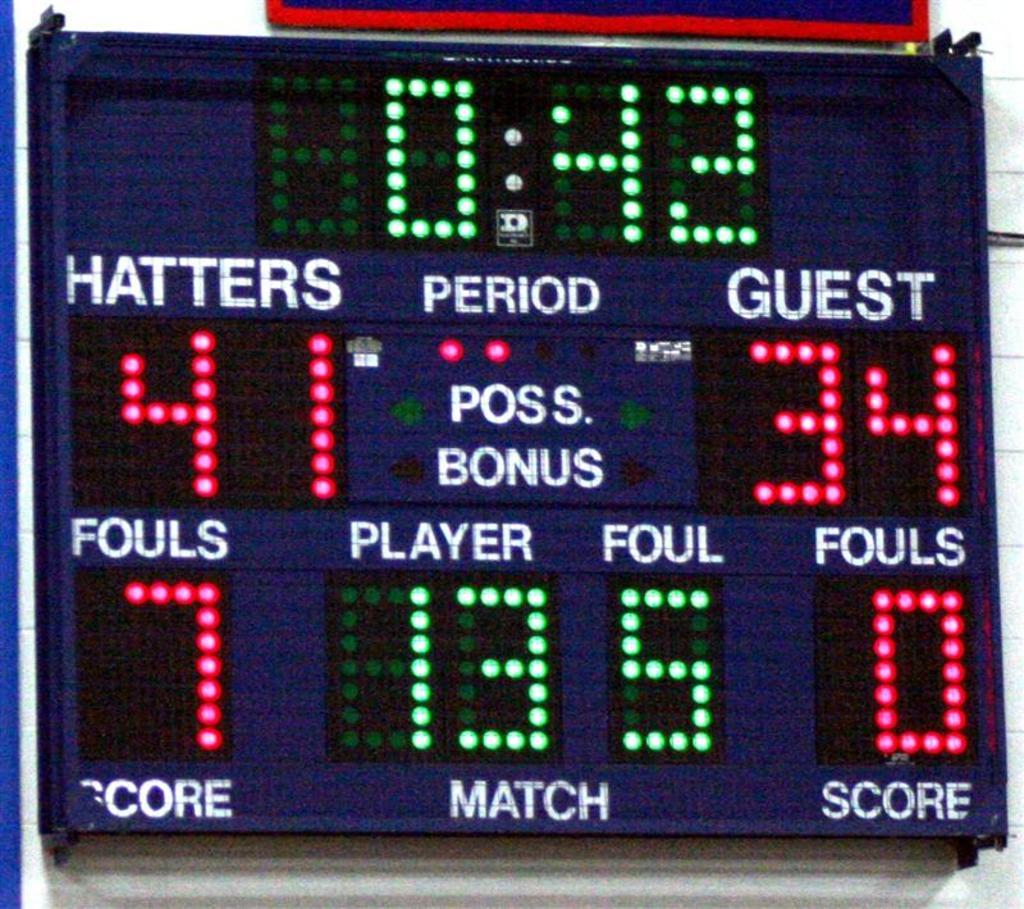Who is the home team?
Your answer should be very brief. Hatters. How many points do the guest have?
Ensure brevity in your answer.  34. 